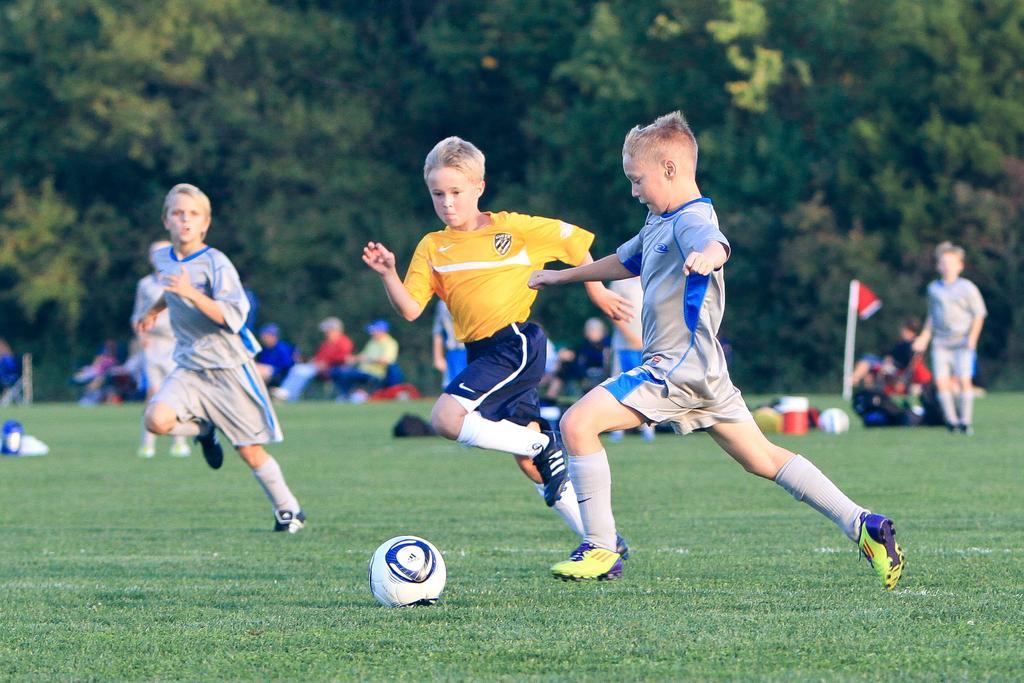Describe this image in one or two sentences. In this image we can see few people are playing soccer. There is a soccer ground in the image. There are many trees in the image. There are few people sitting on the chairs. There are many objects on the ground. 